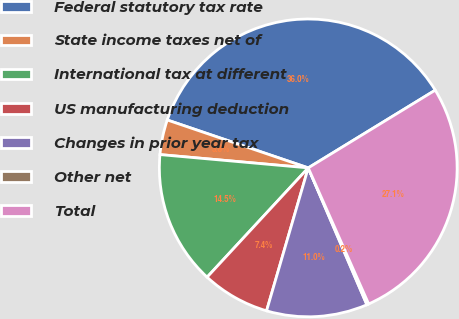Convert chart. <chart><loc_0><loc_0><loc_500><loc_500><pie_chart><fcel>Federal statutory tax rate<fcel>State income taxes net of<fcel>International tax at different<fcel>US manufacturing deduction<fcel>Changes in prior year tax<fcel>Other net<fcel>Total<nl><fcel>36.05%<fcel>3.79%<fcel>14.54%<fcel>7.37%<fcel>10.96%<fcel>0.21%<fcel>27.09%<nl></chart> 